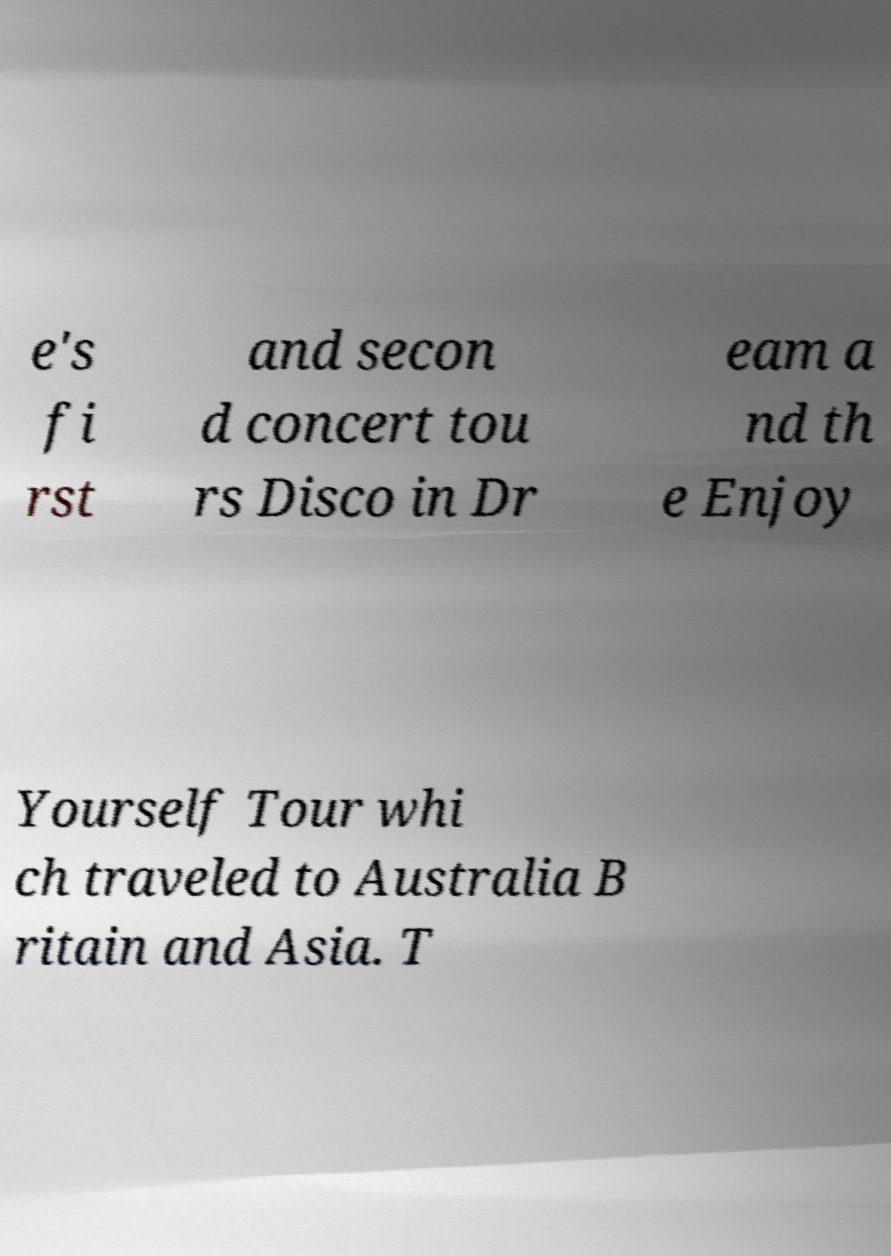Can you read and provide the text displayed in the image?This photo seems to have some interesting text. Can you extract and type it out for me? e's fi rst and secon d concert tou rs Disco in Dr eam a nd th e Enjoy Yourself Tour whi ch traveled to Australia B ritain and Asia. T 